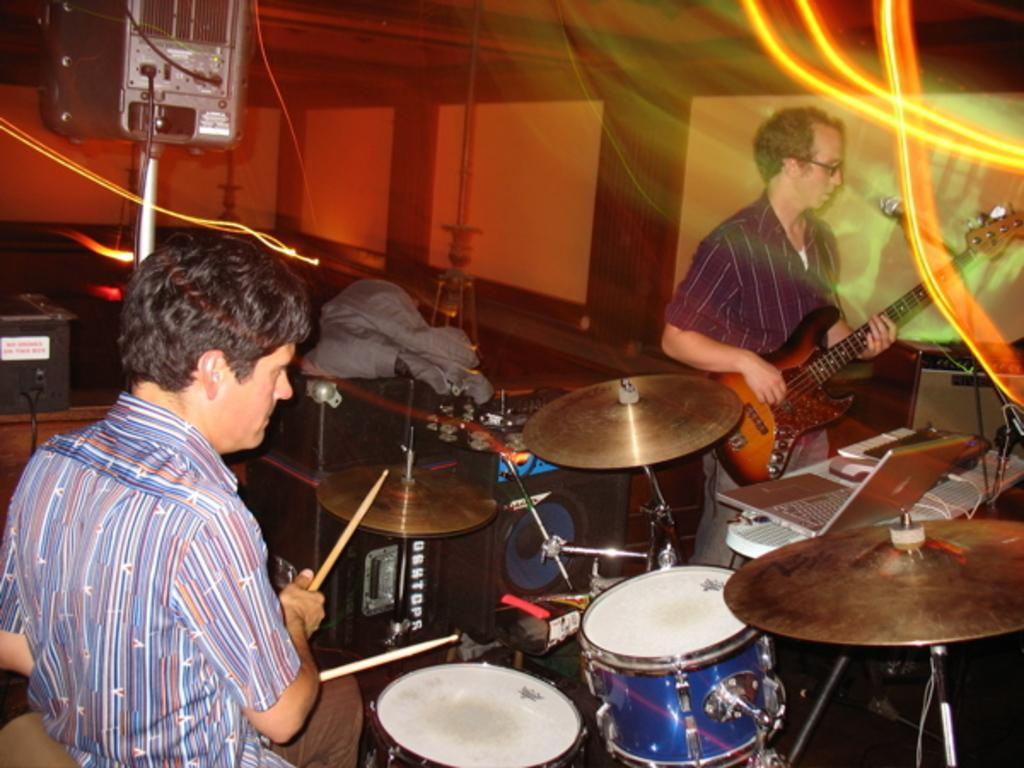How many people are in the image? There are two men in the image. What are the men doing in the image? The men are playing musical instruments. Where are the men located in the image? The men are on a stage. Can you see a cat performing an activity on the stage in the image? There is no cat present in the image, and therefore no such activity can be observed. 